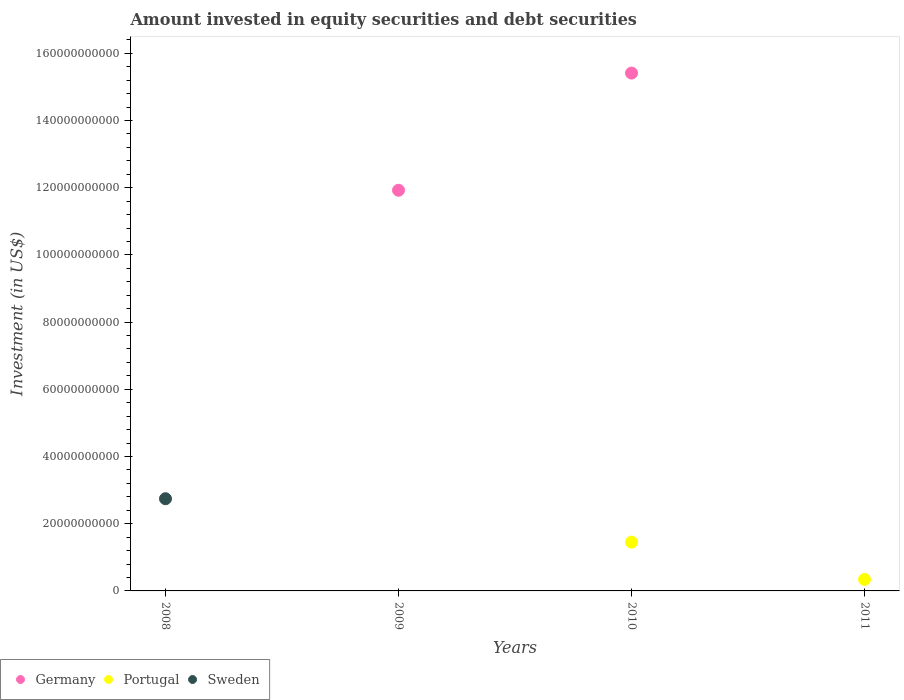Is the number of dotlines equal to the number of legend labels?
Your response must be concise. No. What is the amount invested in equity securities and debt securities in Sweden in 2011?
Give a very brief answer. 0. Across all years, what is the maximum amount invested in equity securities and debt securities in Sweden?
Offer a very short reply. 2.74e+1. In which year was the amount invested in equity securities and debt securities in Sweden maximum?
Provide a short and direct response. 2008. What is the total amount invested in equity securities and debt securities in Portugal in the graph?
Provide a succinct answer. 1.79e+1. What is the difference between the amount invested in equity securities and debt securities in Germany in 2011 and the amount invested in equity securities and debt securities in Sweden in 2010?
Your response must be concise. 0. What is the average amount invested in equity securities and debt securities in Portugal per year?
Your response must be concise. 4.49e+09. In the year 2010, what is the difference between the amount invested in equity securities and debt securities in Germany and amount invested in equity securities and debt securities in Portugal?
Keep it short and to the point. 1.40e+11. What is the difference between the highest and the lowest amount invested in equity securities and debt securities in Portugal?
Your response must be concise. 1.45e+1. In how many years, is the amount invested in equity securities and debt securities in Sweden greater than the average amount invested in equity securities and debt securities in Sweden taken over all years?
Give a very brief answer. 1. Is it the case that in every year, the sum of the amount invested in equity securities and debt securities in Portugal and amount invested in equity securities and debt securities in Sweden  is greater than the amount invested in equity securities and debt securities in Germany?
Your response must be concise. No. Is the amount invested in equity securities and debt securities in Germany strictly greater than the amount invested in equity securities and debt securities in Portugal over the years?
Your answer should be compact. No. Is the amount invested in equity securities and debt securities in Germany strictly less than the amount invested in equity securities and debt securities in Sweden over the years?
Offer a very short reply. No. How many dotlines are there?
Offer a very short reply. 3. What is the difference between two consecutive major ticks on the Y-axis?
Keep it short and to the point. 2.00e+1. Does the graph contain any zero values?
Your answer should be very brief. Yes. Does the graph contain grids?
Ensure brevity in your answer.  No. How many legend labels are there?
Offer a very short reply. 3. How are the legend labels stacked?
Your answer should be very brief. Horizontal. What is the title of the graph?
Make the answer very short. Amount invested in equity securities and debt securities. Does "Yemen, Rep." appear as one of the legend labels in the graph?
Your answer should be very brief. No. What is the label or title of the X-axis?
Your answer should be very brief. Years. What is the label or title of the Y-axis?
Your answer should be very brief. Investment (in US$). What is the Investment (in US$) in Sweden in 2008?
Give a very brief answer. 2.74e+1. What is the Investment (in US$) in Germany in 2009?
Ensure brevity in your answer.  1.19e+11. What is the Investment (in US$) in Sweden in 2009?
Your response must be concise. 0. What is the Investment (in US$) in Germany in 2010?
Provide a succinct answer. 1.54e+11. What is the Investment (in US$) of Portugal in 2010?
Provide a succinct answer. 1.45e+1. What is the Investment (in US$) in Portugal in 2011?
Provide a succinct answer. 3.42e+09. What is the Investment (in US$) in Sweden in 2011?
Keep it short and to the point. 0. Across all years, what is the maximum Investment (in US$) of Germany?
Give a very brief answer. 1.54e+11. Across all years, what is the maximum Investment (in US$) of Portugal?
Make the answer very short. 1.45e+1. Across all years, what is the maximum Investment (in US$) in Sweden?
Provide a succinct answer. 2.74e+1. Across all years, what is the minimum Investment (in US$) of Portugal?
Provide a succinct answer. 0. Across all years, what is the minimum Investment (in US$) in Sweden?
Give a very brief answer. 0. What is the total Investment (in US$) in Germany in the graph?
Ensure brevity in your answer.  2.73e+11. What is the total Investment (in US$) of Portugal in the graph?
Your answer should be compact. 1.79e+1. What is the total Investment (in US$) in Sweden in the graph?
Ensure brevity in your answer.  2.74e+1. What is the difference between the Investment (in US$) in Germany in 2009 and that in 2010?
Provide a short and direct response. -3.49e+1. What is the difference between the Investment (in US$) of Portugal in 2010 and that in 2011?
Provide a succinct answer. 1.11e+1. What is the difference between the Investment (in US$) of Germany in 2009 and the Investment (in US$) of Portugal in 2010?
Provide a short and direct response. 1.05e+11. What is the difference between the Investment (in US$) of Germany in 2009 and the Investment (in US$) of Portugal in 2011?
Give a very brief answer. 1.16e+11. What is the difference between the Investment (in US$) of Germany in 2010 and the Investment (in US$) of Portugal in 2011?
Your answer should be compact. 1.51e+11. What is the average Investment (in US$) in Germany per year?
Provide a succinct answer. 6.83e+1. What is the average Investment (in US$) of Portugal per year?
Keep it short and to the point. 4.49e+09. What is the average Investment (in US$) in Sweden per year?
Provide a succinct answer. 6.86e+09. In the year 2010, what is the difference between the Investment (in US$) of Germany and Investment (in US$) of Portugal?
Give a very brief answer. 1.40e+11. What is the ratio of the Investment (in US$) of Germany in 2009 to that in 2010?
Your response must be concise. 0.77. What is the ratio of the Investment (in US$) in Portugal in 2010 to that in 2011?
Your answer should be compact. 4.25. What is the difference between the highest and the lowest Investment (in US$) of Germany?
Your answer should be very brief. 1.54e+11. What is the difference between the highest and the lowest Investment (in US$) of Portugal?
Make the answer very short. 1.45e+1. What is the difference between the highest and the lowest Investment (in US$) in Sweden?
Ensure brevity in your answer.  2.74e+1. 